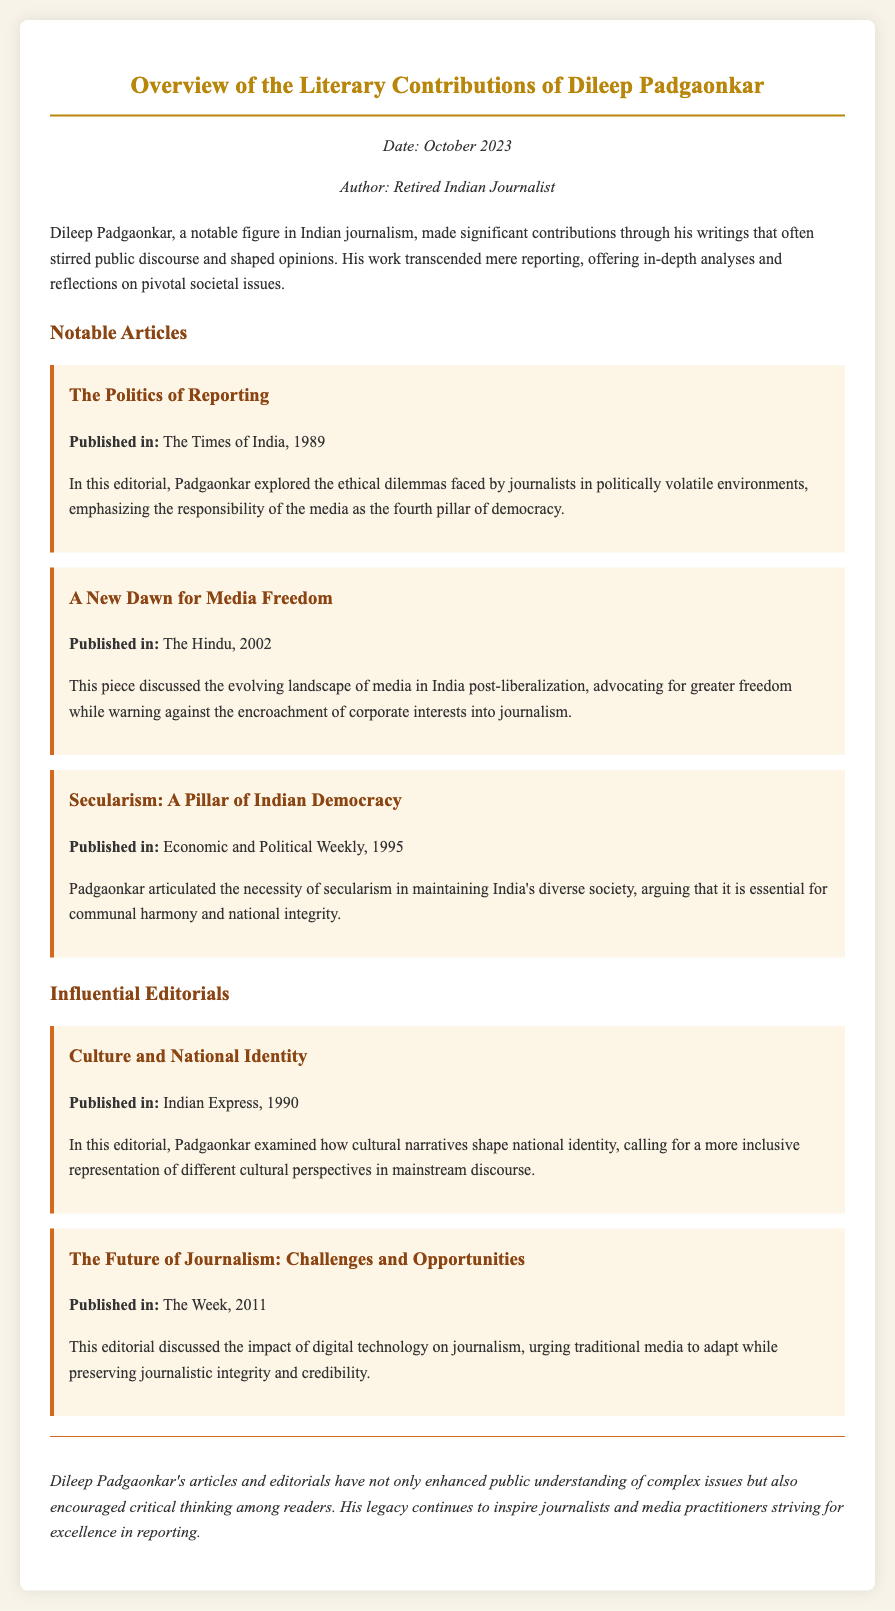What is the date of the memo? The date is mentioned at the top of the memo in the metadata section.
Answer: October 2023 Who is the author of the memo? The author's name is provided in the metadata section of the document.
Answer: Retired Indian Journalist Which article was published in The Times of India? The titles of the articles are listed, along with their publication sources.
Answer: The Politics of Reporting What was the primary concern in the article "A New Dawn for Media Freedom"? The article describes themes which can be inferred by examining its content summary.
Answer: Media freedom and corporate interests In which year was "Secularism: A Pillar of Indian Democracy" published? The publication dates for the articles are provided in their descriptions.
Answer: 1995 What major theme is discussed in the editorial "The Future of Journalism: Challenges and Opportunities"? Key themes for editorials can be identified by analyzing their summaries.
Answer: Impact of digital technology How many notable articles are mentioned in the memo? The articles are listed, so counting them provides the answer.
Answer: Three What does the conclusion highlight about Padgaonkar's legacy? The conclusion summarizes the overall impact of his work on public understanding and journalism.
Answer: Inspire journalists and media practitioners 